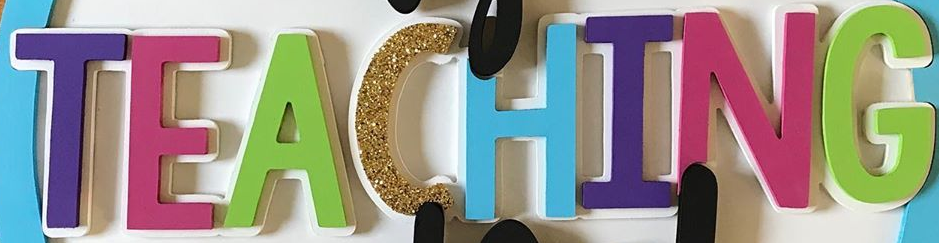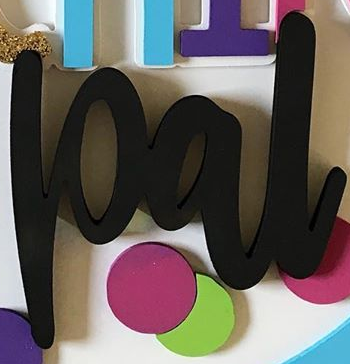Identify the words shown in these images in order, separated by a semicolon. TEACHING; pal 